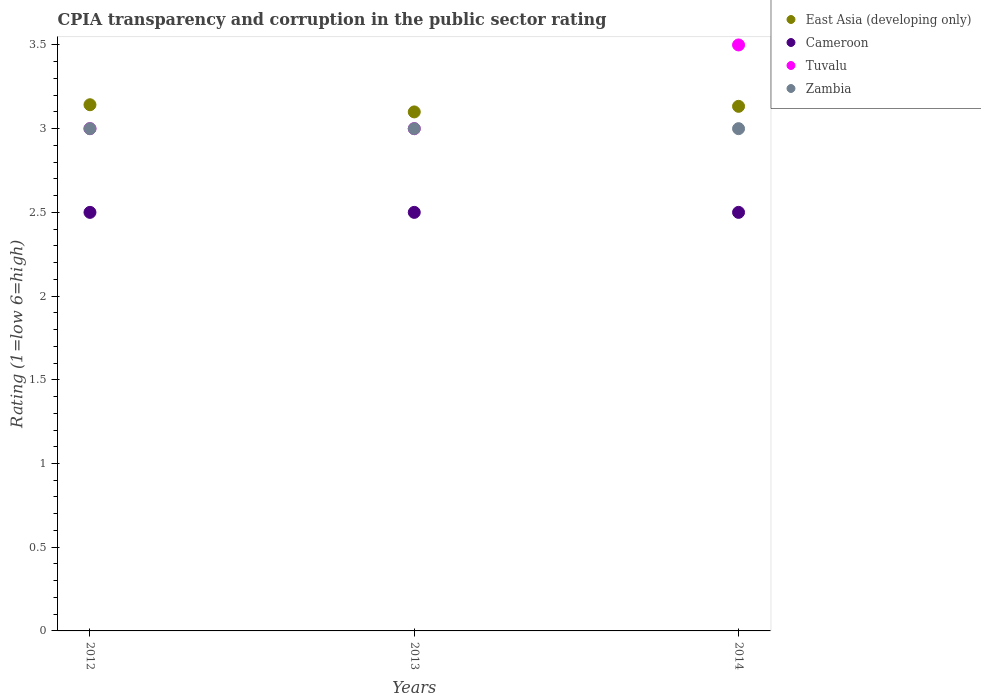Is the number of dotlines equal to the number of legend labels?
Your answer should be very brief. Yes. What is the CPIA rating in Tuvalu in 2013?
Offer a very short reply. 3. Across all years, what is the maximum CPIA rating in Cameroon?
Give a very brief answer. 2.5. In which year was the CPIA rating in Zambia minimum?
Your response must be concise. 2012. What is the total CPIA rating in East Asia (developing only) in the graph?
Provide a short and direct response. 9.38. What is the difference between the CPIA rating in Cameroon in 2013 and the CPIA rating in East Asia (developing only) in 2012?
Your answer should be compact. -0.64. What is the average CPIA rating in Zambia per year?
Your answer should be very brief. 3. In the year 2013, what is the difference between the CPIA rating in East Asia (developing only) and CPIA rating in Tuvalu?
Offer a very short reply. 0.1. In how many years, is the CPIA rating in Cameroon greater than 0.4?
Provide a succinct answer. 3. What is the ratio of the CPIA rating in East Asia (developing only) in 2012 to that in 2013?
Provide a succinct answer. 1.01. Is the CPIA rating in Zambia in 2012 less than that in 2014?
Your response must be concise. No. Is the difference between the CPIA rating in East Asia (developing only) in 2012 and 2014 greater than the difference between the CPIA rating in Tuvalu in 2012 and 2014?
Provide a short and direct response. Yes. Is it the case that in every year, the sum of the CPIA rating in Tuvalu and CPIA rating in Cameroon  is greater than the sum of CPIA rating in East Asia (developing only) and CPIA rating in Zambia?
Your answer should be compact. No. Does the CPIA rating in Tuvalu monotonically increase over the years?
Provide a succinct answer. No. Is the CPIA rating in Zambia strictly greater than the CPIA rating in Cameroon over the years?
Ensure brevity in your answer.  Yes. How many dotlines are there?
Provide a short and direct response. 4. What is the difference between two consecutive major ticks on the Y-axis?
Provide a succinct answer. 0.5. Does the graph contain any zero values?
Your answer should be compact. No. Does the graph contain grids?
Keep it short and to the point. No. How many legend labels are there?
Give a very brief answer. 4. How are the legend labels stacked?
Your answer should be very brief. Vertical. What is the title of the graph?
Provide a succinct answer. CPIA transparency and corruption in the public sector rating. What is the label or title of the X-axis?
Keep it short and to the point. Years. What is the label or title of the Y-axis?
Provide a short and direct response. Rating (1=low 6=high). What is the Rating (1=low 6=high) of East Asia (developing only) in 2012?
Your answer should be very brief. 3.14. What is the Rating (1=low 6=high) in Tuvalu in 2012?
Keep it short and to the point. 3. What is the Rating (1=low 6=high) of East Asia (developing only) in 2014?
Provide a short and direct response. 3.13. What is the Rating (1=low 6=high) in Cameroon in 2014?
Provide a succinct answer. 2.5. What is the Rating (1=low 6=high) of Tuvalu in 2014?
Offer a very short reply. 3.5. What is the Rating (1=low 6=high) of Zambia in 2014?
Make the answer very short. 3. Across all years, what is the maximum Rating (1=low 6=high) in East Asia (developing only)?
Your response must be concise. 3.14. Across all years, what is the minimum Rating (1=low 6=high) in East Asia (developing only)?
Ensure brevity in your answer.  3.1. Across all years, what is the minimum Rating (1=low 6=high) in Cameroon?
Give a very brief answer. 2.5. What is the total Rating (1=low 6=high) of East Asia (developing only) in the graph?
Offer a terse response. 9.38. What is the total Rating (1=low 6=high) of Cameroon in the graph?
Provide a short and direct response. 7.5. What is the total Rating (1=low 6=high) of Zambia in the graph?
Ensure brevity in your answer.  9. What is the difference between the Rating (1=low 6=high) in East Asia (developing only) in 2012 and that in 2013?
Provide a short and direct response. 0.04. What is the difference between the Rating (1=low 6=high) in Tuvalu in 2012 and that in 2013?
Offer a terse response. 0. What is the difference between the Rating (1=low 6=high) of East Asia (developing only) in 2012 and that in 2014?
Your answer should be very brief. 0.01. What is the difference between the Rating (1=low 6=high) in Tuvalu in 2012 and that in 2014?
Give a very brief answer. -0.5. What is the difference between the Rating (1=low 6=high) of East Asia (developing only) in 2013 and that in 2014?
Provide a succinct answer. -0.03. What is the difference between the Rating (1=low 6=high) of Cameroon in 2013 and that in 2014?
Offer a very short reply. 0. What is the difference between the Rating (1=low 6=high) of Tuvalu in 2013 and that in 2014?
Your answer should be very brief. -0.5. What is the difference between the Rating (1=low 6=high) of East Asia (developing only) in 2012 and the Rating (1=low 6=high) of Cameroon in 2013?
Make the answer very short. 0.64. What is the difference between the Rating (1=low 6=high) in East Asia (developing only) in 2012 and the Rating (1=low 6=high) in Tuvalu in 2013?
Provide a succinct answer. 0.14. What is the difference between the Rating (1=low 6=high) in East Asia (developing only) in 2012 and the Rating (1=low 6=high) in Zambia in 2013?
Offer a very short reply. 0.14. What is the difference between the Rating (1=low 6=high) of Cameroon in 2012 and the Rating (1=low 6=high) of Tuvalu in 2013?
Your answer should be very brief. -0.5. What is the difference between the Rating (1=low 6=high) in Cameroon in 2012 and the Rating (1=low 6=high) in Zambia in 2013?
Provide a short and direct response. -0.5. What is the difference between the Rating (1=low 6=high) in East Asia (developing only) in 2012 and the Rating (1=low 6=high) in Cameroon in 2014?
Ensure brevity in your answer.  0.64. What is the difference between the Rating (1=low 6=high) of East Asia (developing only) in 2012 and the Rating (1=low 6=high) of Tuvalu in 2014?
Keep it short and to the point. -0.36. What is the difference between the Rating (1=low 6=high) in East Asia (developing only) in 2012 and the Rating (1=low 6=high) in Zambia in 2014?
Provide a short and direct response. 0.14. What is the difference between the Rating (1=low 6=high) of Tuvalu in 2012 and the Rating (1=low 6=high) of Zambia in 2014?
Your response must be concise. 0. What is the difference between the Rating (1=low 6=high) of East Asia (developing only) in 2013 and the Rating (1=low 6=high) of Cameroon in 2014?
Your response must be concise. 0.6. What is the difference between the Rating (1=low 6=high) in Cameroon in 2013 and the Rating (1=low 6=high) in Zambia in 2014?
Provide a succinct answer. -0.5. What is the difference between the Rating (1=low 6=high) in Tuvalu in 2013 and the Rating (1=low 6=high) in Zambia in 2014?
Give a very brief answer. 0. What is the average Rating (1=low 6=high) of East Asia (developing only) per year?
Offer a very short reply. 3.13. What is the average Rating (1=low 6=high) in Cameroon per year?
Make the answer very short. 2.5. What is the average Rating (1=low 6=high) of Tuvalu per year?
Keep it short and to the point. 3.17. In the year 2012, what is the difference between the Rating (1=low 6=high) of East Asia (developing only) and Rating (1=low 6=high) of Cameroon?
Give a very brief answer. 0.64. In the year 2012, what is the difference between the Rating (1=low 6=high) in East Asia (developing only) and Rating (1=low 6=high) in Tuvalu?
Your answer should be compact. 0.14. In the year 2012, what is the difference between the Rating (1=low 6=high) of East Asia (developing only) and Rating (1=low 6=high) of Zambia?
Your response must be concise. 0.14. In the year 2012, what is the difference between the Rating (1=low 6=high) in Cameroon and Rating (1=low 6=high) in Zambia?
Ensure brevity in your answer.  -0.5. In the year 2013, what is the difference between the Rating (1=low 6=high) of Cameroon and Rating (1=low 6=high) of Tuvalu?
Make the answer very short. -0.5. In the year 2013, what is the difference between the Rating (1=low 6=high) of Cameroon and Rating (1=low 6=high) of Zambia?
Your answer should be very brief. -0.5. In the year 2014, what is the difference between the Rating (1=low 6=high) of East Asia (developing only) and Rating (1=low 6=high) of Cameroon?
Ensure brevity in your answer.  0.63. In the year 2014, what is the difference between the Rating (1=low 6=high) in East Asia (developing only) and Rating (1=low 6=high) in Tuvalu?
Provide a short and direct response. -0.37. In the year 2014, what is the difference between the Rating (1=low 6=high) of East Asia (developing only) and Rating (1=low 6=high) of Zambia?
Give a very brief answer. 0.13. What is the ratio of the Rating (1=low 6=high) in East Asia (developing only) in 2012 to that in 2013?
Offer a very short reply. 1.01. What is the ratio of the Rating (1=low 6=high) in Tuvalu in 2012 to that in 2013?
Your answer should be very brief. 1. What is the ratio of the Rating (1=low 6=high) of East Asia (developing only) in 2012 to that in 2014?
Give a very brief answer. 1. What is the ratio of the Rating (1=low 6=high) of Cameroon in 2012 to that in 2014?
Provide a short and direct response. 1. What is the ratio of the Rating (1=low 6=high) of Cameroon in 2013 to that in 2014?
Offer a terse response. 1. What is the difference between the highest and the second highest Rating (1=low 6=high) of East Asia (developing only)?
Your answer should be compact. 0.01. What is the difference between the highest and the second highest Rating (1=low 6=high) of Cameroon?
Offer a very short reply. 0. What is the difference between the highest and the lowest Rating (1=low 6=high) of East Asia (developing only)?
Provide a succinct answer. 0.04. What is the difference between the highest and the lowest Rating (1=low 6=high) of Cameroon?
Provide a short and direct response. 0. What is the difference between the highest and the lowest Rating (1=low 6=high) in Tuvalu?
Provide a short and direct response. 0.5. 